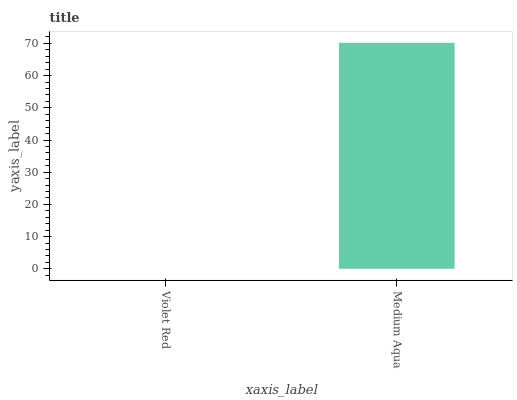Is Violet Red the minimum?
Answer yes or no. Yes. Is Medium Aqua the maximum?
Answer yes or no. Yes. Is Medium Aqua the minimum?
Answer yes or no. No. Is Medium Aqua greater than Violet Red?
Answer yes or no. Yes. Is Violet Red less than Medium Aqua?
Answer yes or no. Yes. Is Violet Red greater than Medium Aqua?
Answer yes or no. No. Is Medium Aqua less than Violet Red?
Answer yes or no. No. Is Medium Aqua the high median?
Answer yes or no. Yes. Is Violet Red the low median?
Answer yes or no. Yes. Is Violet Red the high median?
Answer yes or no. No. Is Medium Aqua the low median?
Answer yes or no. No. 